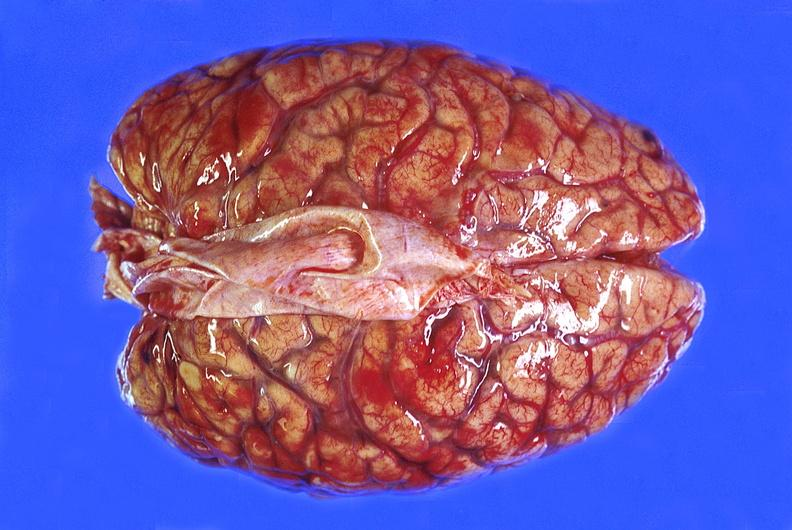what does this image show?
Answer the question using a single word or phrase. Brain abscess 